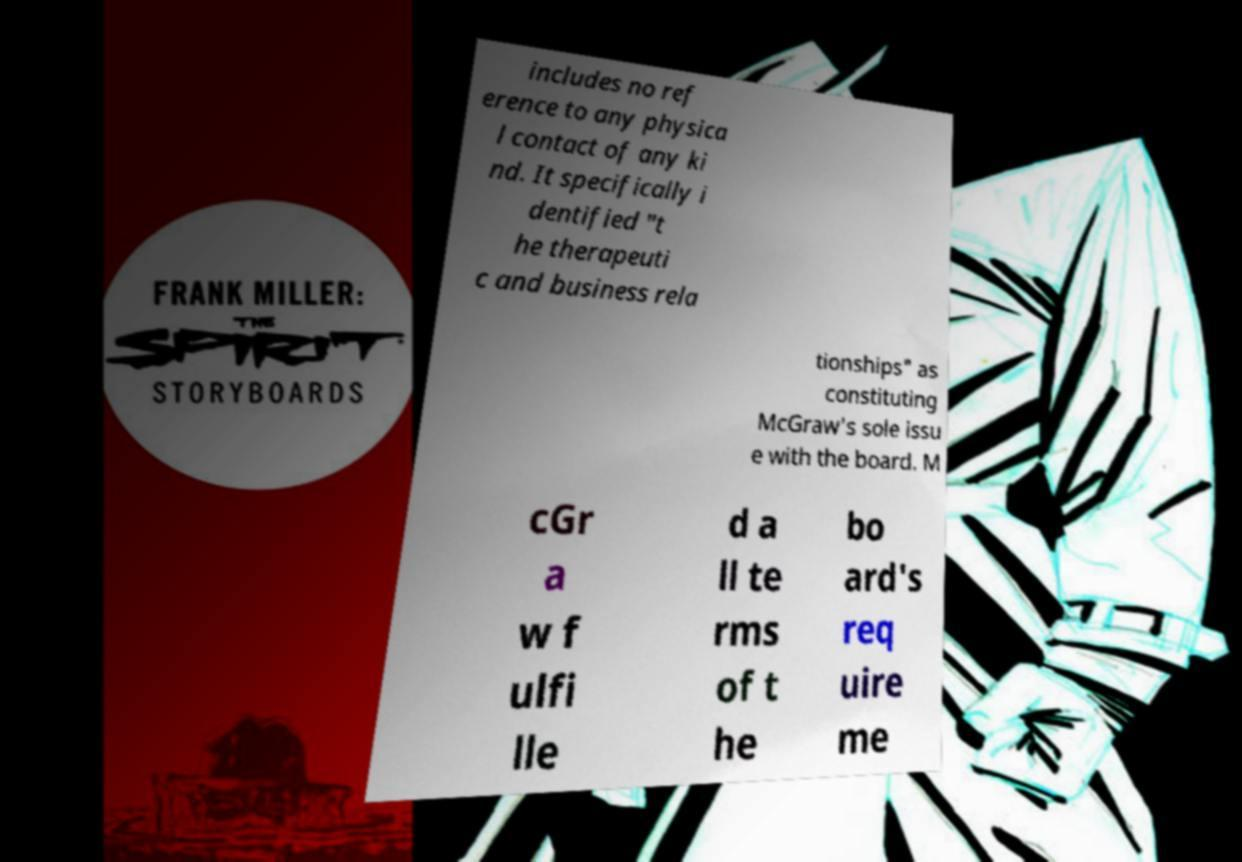There's text embedded in this image that I need extracted. Can you transcribe it verbatim? includes no ref erence to any physica l contact of any ki nd. It specifically i dentified "t he therapeuti c and business rela tionships" as constituting McGraw's sole issu e with the board. M cGr a w f ulfi lle d a ll te rms of t he bo ard's req uire me 